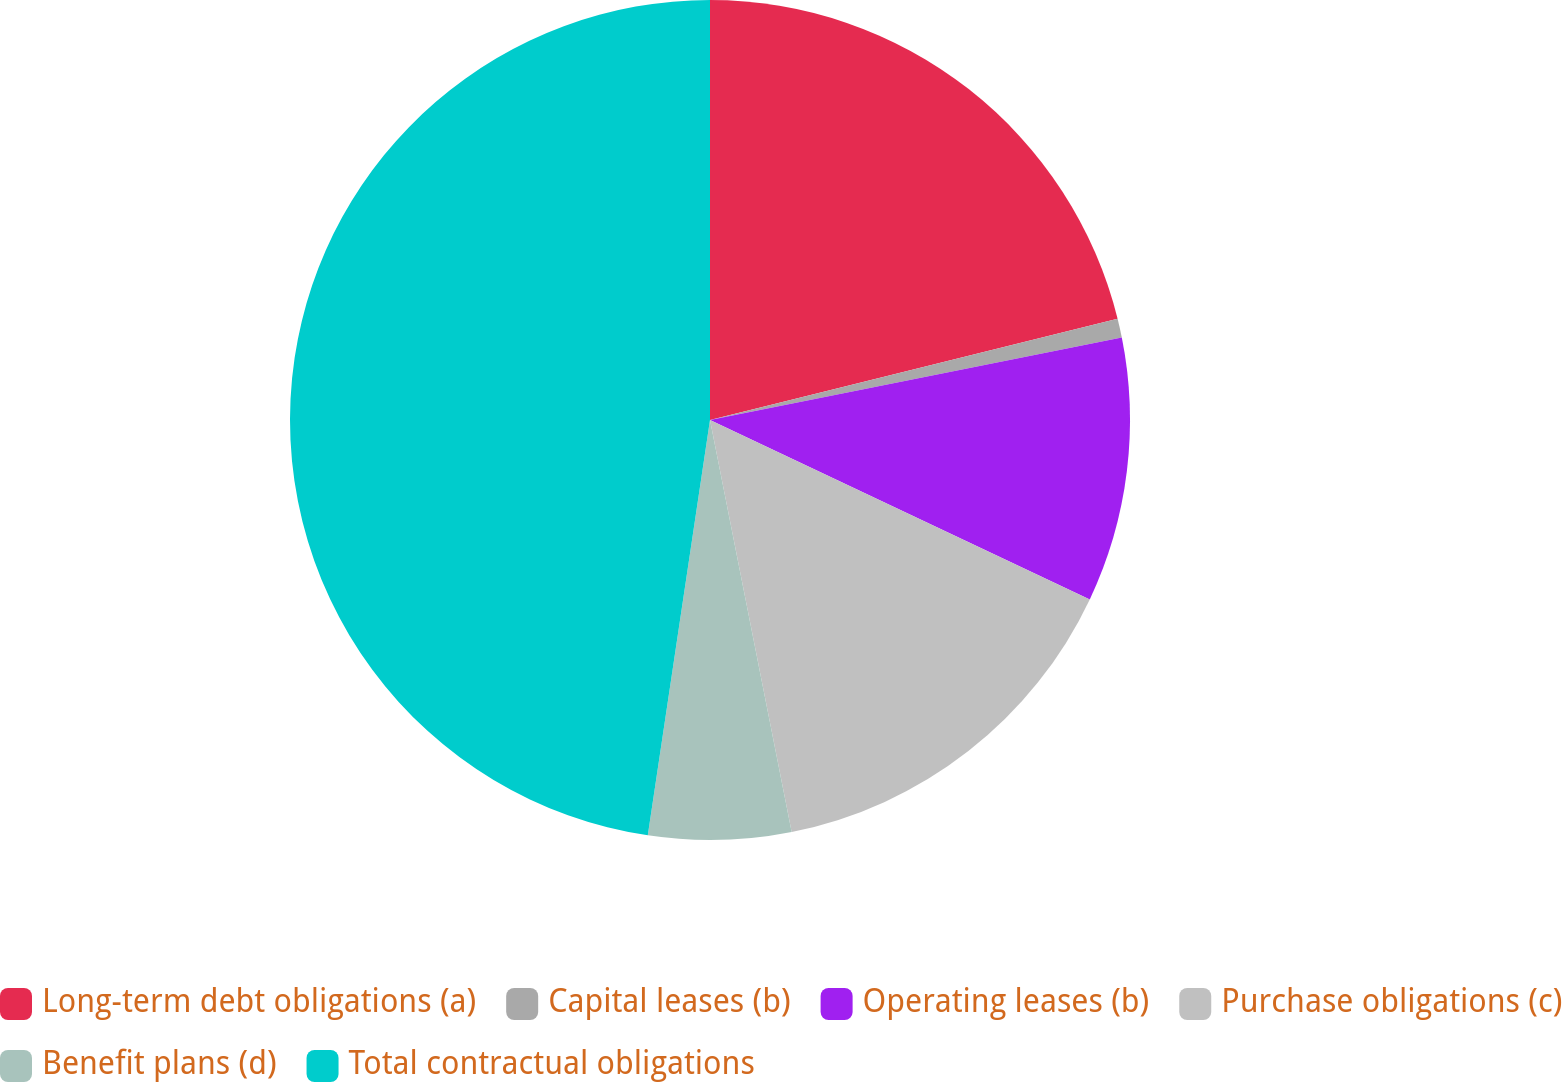Convert chart to OTSL. <chart><loc_0><loc_0><loc_500><loc_500><pie_chart><fcel>Long-term debt obligations (a)<fcel>Capital leases (b)<fcel>Operating leases (b)<fcel>Purchase obligations (c)<fcel>Benefit plans (d)<fcel>Total contractual obligations<nl><fcel>21.12%<fcel>0.73%<fcel>10.17%<fcel>14.86%<fcel>5.48%<fcel>47.63%<nl></chart> 